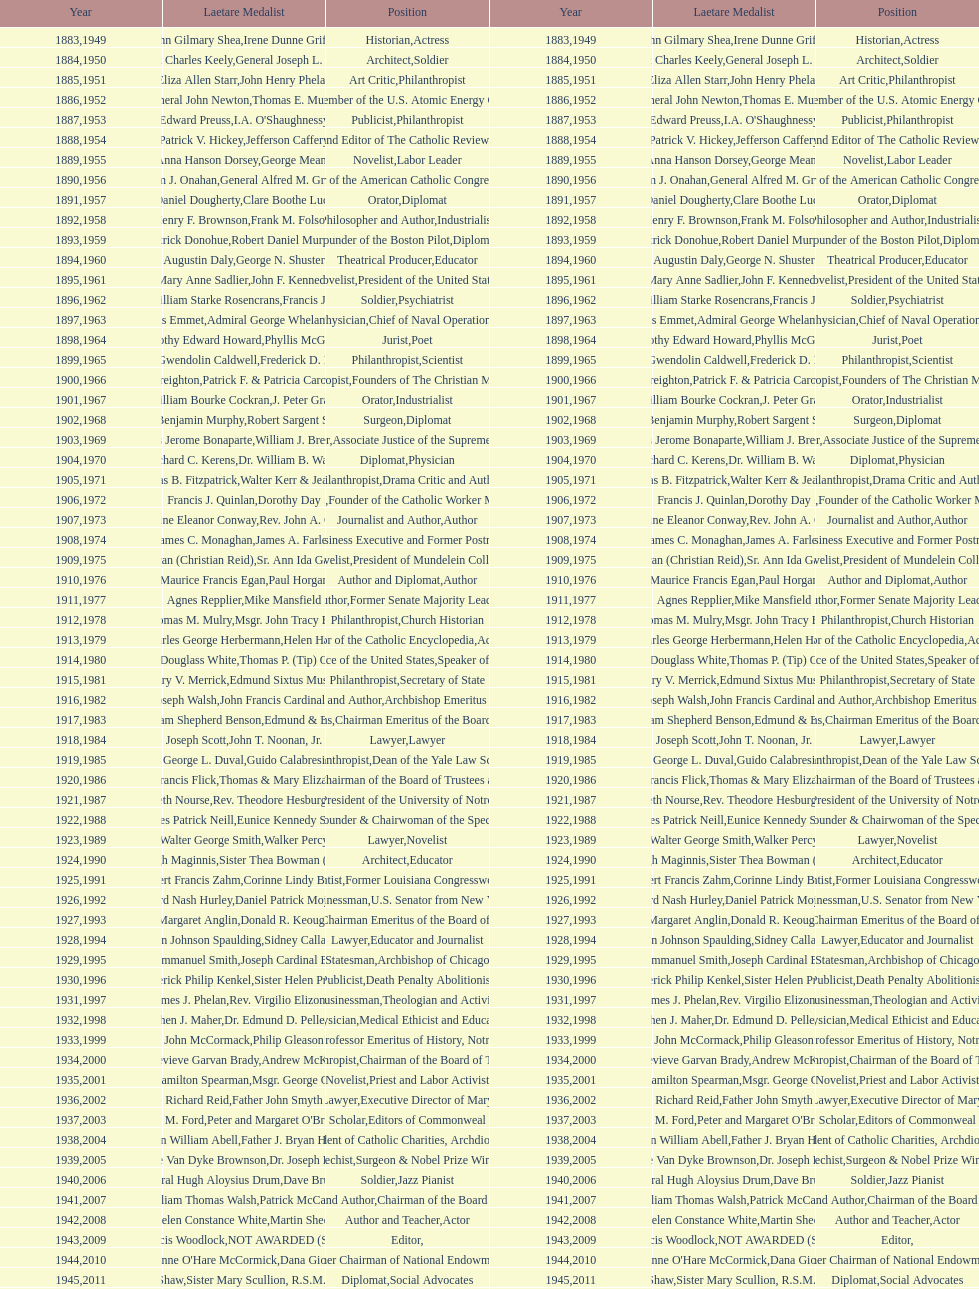What is the cumulative number of occurrences of soldier being stated as the position on this chart? 4. 